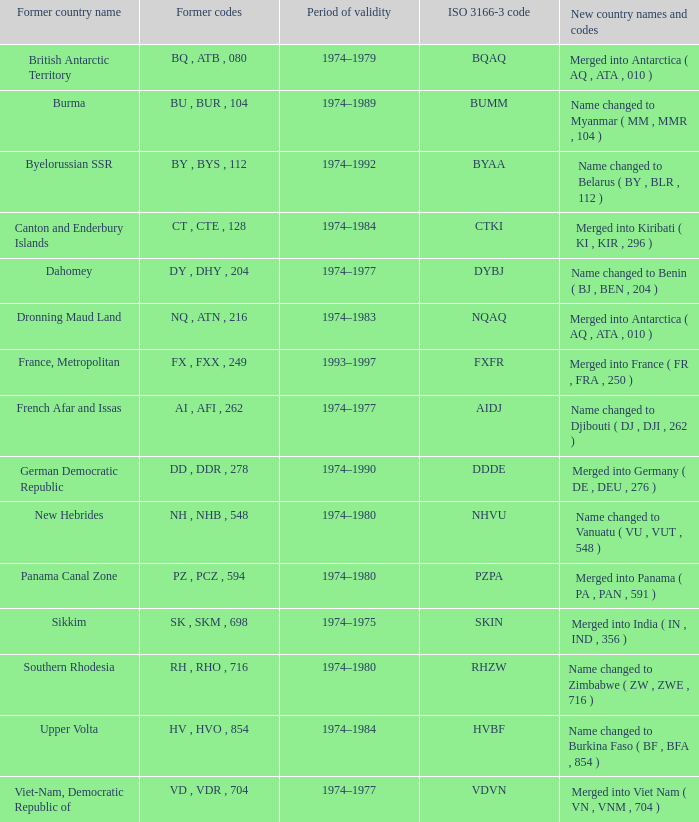Specify the overall duration of validity for upper volta. 1.0. 